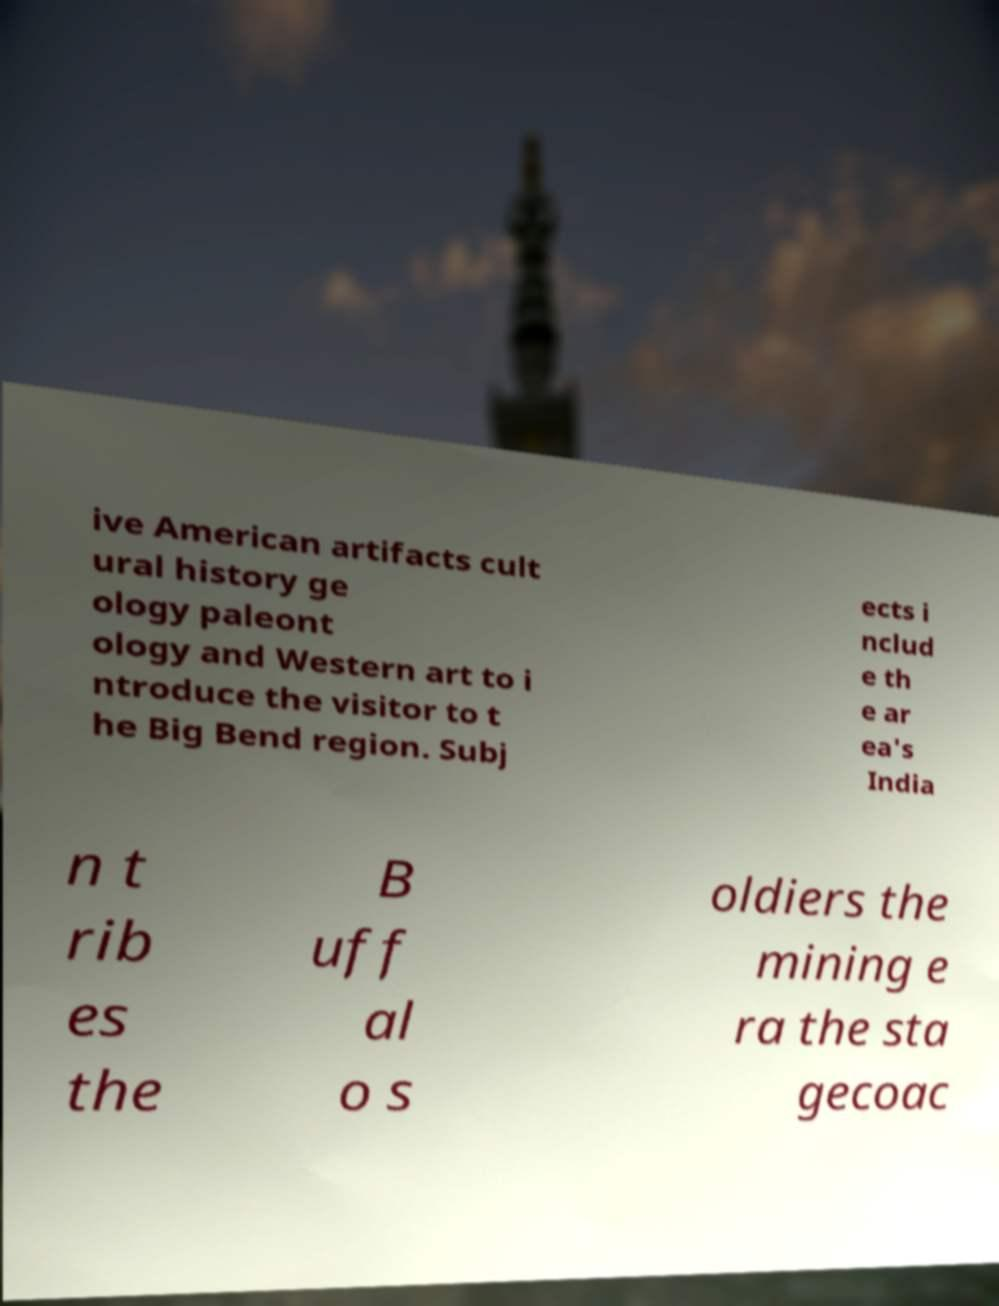Can you accurately transcribe the text from the provided image for me? ive American artifacts cult ural history ge ology paleont ology and Western art to i ntroduce the visitor to t he Big Bend region. Subj ects i nclud e th e ar ea's India n t rib es the B uff al o s oldiers the mining e ra the sta gecoac 